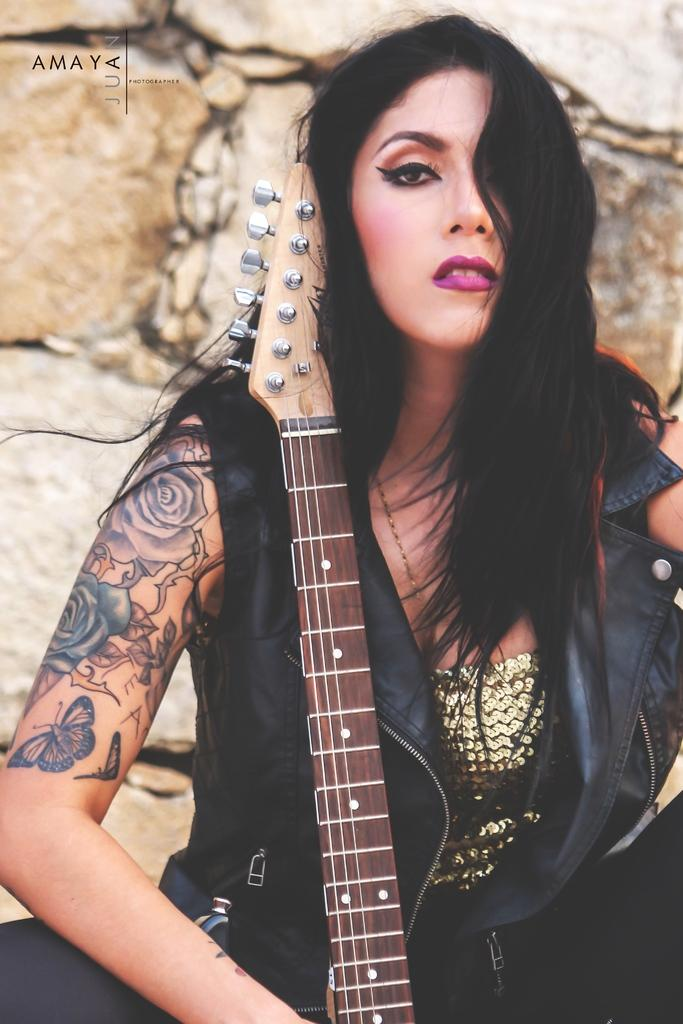Who is present in the image? There is a woman in the image. What is the woman doing in the image? The woman is sitting in the image. What object is the woman holding in her hand? The woman is holding a guitar in her hand. What type of milk is the woman drinking in the image? There is no milk present in the image. 